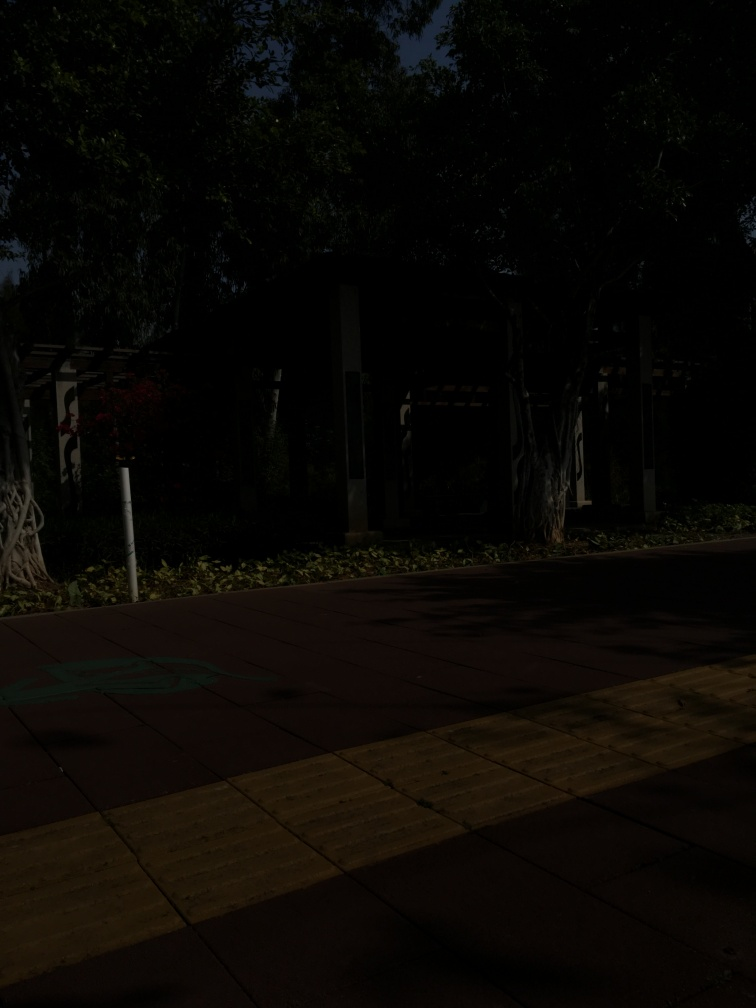Are the main subjects of the image sidewalks? Yes, the image prominently features sidewalks, with a focus on the patterned paved blocks creating a pathway for pedestrians. The sidewalks seem to serve as a walkway within a park or garden-like setting, surrounded by trees and vegetation. 